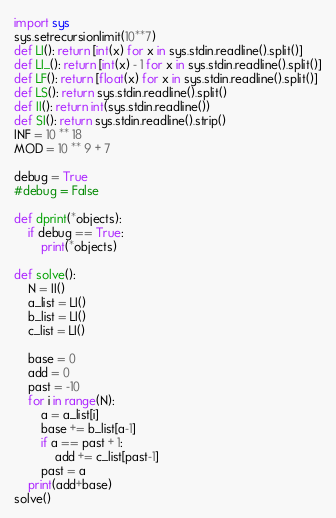<code> <loc_0><loc_0><loc_500><loc_500><_Python_>import sys
sys.setrecursionlimit(10**7)
def LI(): return [int(x) for x in sys.stdin.readline().split()]
def LI_(): return [int(x) - 1 for x in sys.stdin.readline().split()]
def LF(): return [float(x) for x in sys.stdin.readline().split()]
def LS(): return sys.stdin.readline().split()
def II(): return int(sys.stdin.readline())
def SI(): return sys.stdin.readline().strip()
INF = 10 ** 18
MOD = 10 ** 9 + 7

debug = True
#debug = False

def dprint(*objects):
    if debug == True:
        print(*objects)

def solve():
    N = II()
    a_list = LI()
    b_list = LI()
    c_list = LI()

    base = 0
    add = 0
    past = -10
    for i in range(N):
        a = a_list[i]
        base += b_list[a-1]
        if a == past + 1:
            add += c_list[past-1]
        past = a
    print(add+base)
solve()</code> 